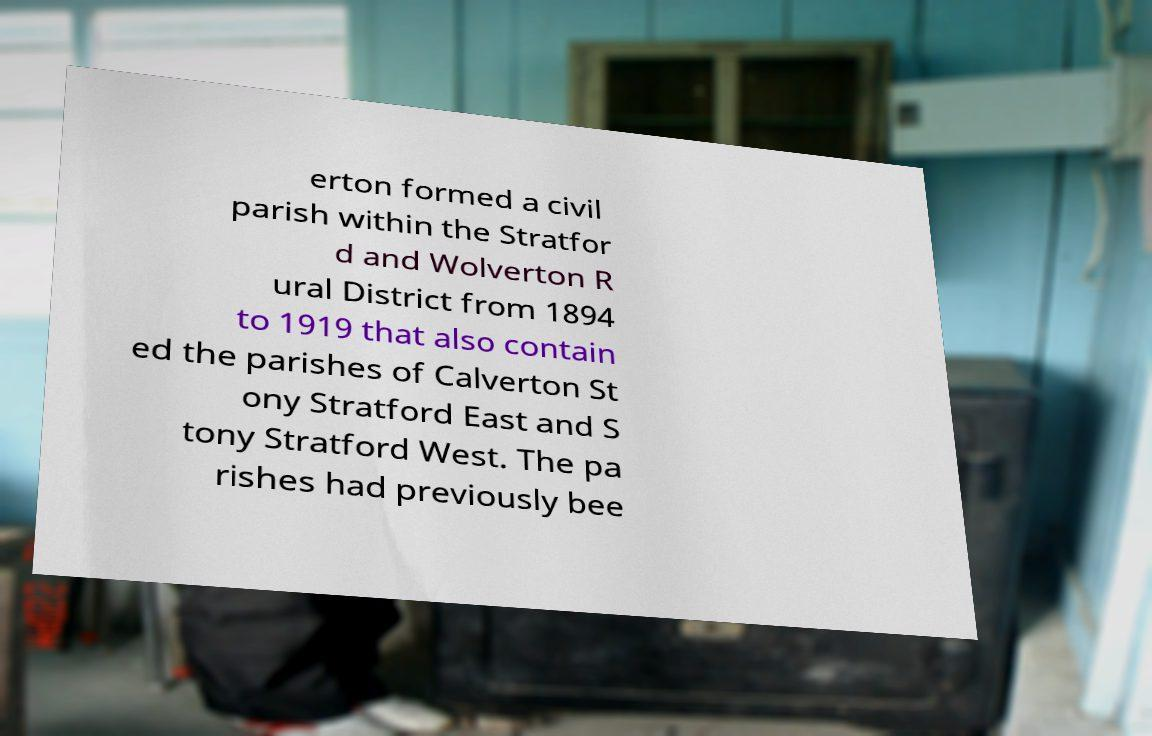Please read and relay the text visible in this image. What does it say? erton formed a civil parish within the Stratfor d and Wolverton R ural District from 1894 to 1919 that also contain ed the parishes of Calverton St ony Stratford East and S tony Stratford West. The pa rishes had previously bee 